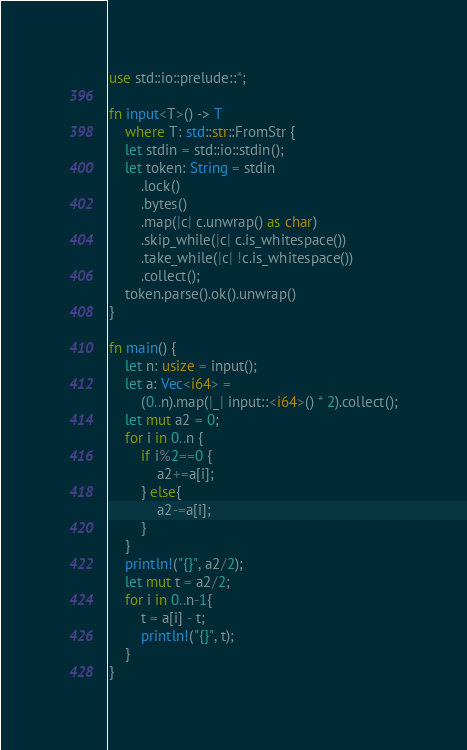<code> <loc_0><loc_0><loc_500><loc_500><_Rust_>use std::io::prelude::*;

fn input<T>() -> T
    where T: std::str::FromStr {
    let stdin = std::io::stdin();
    let token: String = stdin
        .lock()
        .bytes()
        .map(|c| c.unwrap() as char)
        .skip_while(|c| c.is_whitespace())
        .take_while(|c| !c.is_whitespace())
        .collect();
    token.parse().ok().unwrap()
}

fn main() {
    let n: usize = input();
    let a: Vec<i64> =
        (0..n).map(|_| input::<i64>() * 2).collect();
    let mut a2 = 0;
    for i in 0..n {
        if i%2==0 {
            a2+=a[i];
        } else{
            a2-=a[i];
        }
    }
    println!("{}", a2/2);
    let mut t = a2/2;
    for i in 0..n-1{
        t = a[i] - t;
        println!("{}", t);
    }
}</code> 